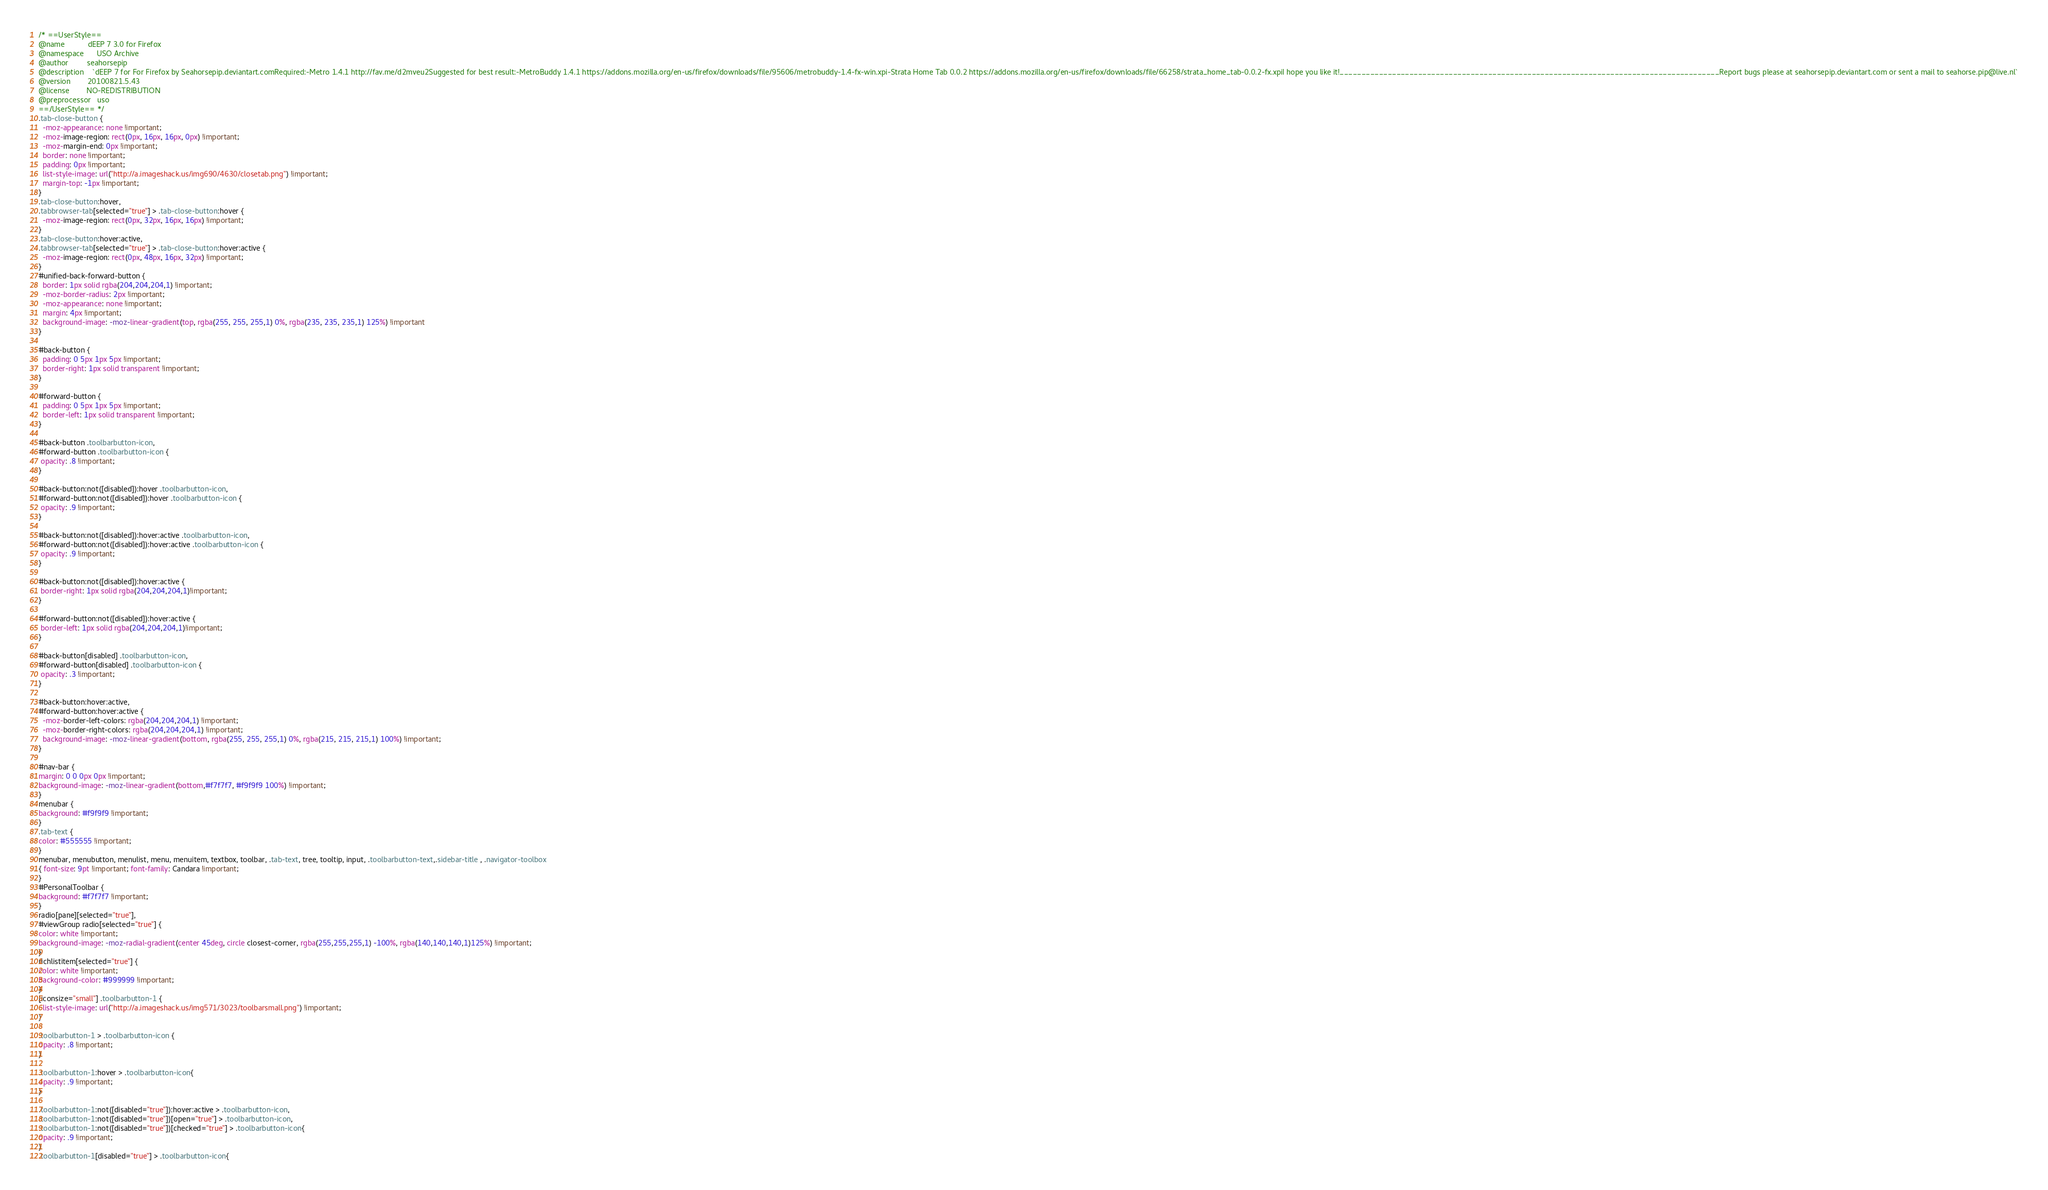<code> <loc_0><loc_0><loc_500><loc_500><_CSS_>/* ==UserStyle==
@name           dEEP 7 3.0 for Firefox
@namespace      USO Archive
@author         seahorsepip
@description    `dEEP 7 for For Firefox by Seahorsepip.deviantart.comRequired:-Metro 1.4.1 http://fav.me/d2mveu2Suggested for best result:-MetroBuddy 1.4.1 https://addons.mozilla.org/en-us/firefox/downloads/file/95606/metrobuddy-1.4-fx-win.xpi-Strata Home Tab 0.0.2 https://addons.mozilla.org/en-us/firefox/downloads/file/66258/strata_home_tab-0.0.2-fx.xpiI hope you like it!_______________________________________________________________________________________Report bugs please at seahorsepip.deviantart.com or sent a mail to seahorse.pip@live.nl`
@version        20100821.5.43
@license        NO-REDISTRIBUTION
@preprocessor   uso
==/UserStyle== */
.tab-close-button {
  -moz-appearance: none !important;
  -moz-image-region: rect(0px, 16px, 16px, 0px) !important;
  -moz-margin-end: 0px !important;
  border: none !important;
  padding: 0px !important;
  list-style-image: url("http://a.imageshack.us/img690/4630/closetab.png") !important;
  margin-top: -1px !important;
}
.tab-close-button:hover,
.tabbrowser-tab[selected="true"] > .tab-close-button:hover {
  -moz-image-region: rect(0px, 32px, 16px, 16px) !important;
}
.tab-close-button:hover:active,
.tabbrowser-tab[selected="true"] > .tab-close-button:hover:active {
  -moz-image-region: rect(0px, 48px, 16px, 32px) !important;
}
#unified-back-forward-button {
  border: 1px solid rgba(204,204,204,1) !important;
  -moz-border-radius: 2px !important;
  -moz-appearance: none !important;
  margin: 4px !important;
  background-image: -moz-linear-gradient(top, rgba(255, 255, 255,1) 0%, rgba(235, 235, 235,1) 125%) !important
}

#back-button {
  padding: 0 5px 1px 5px !important;
  border-right: 1px solid transparent !important;
}

#forward-button {
  padding: 0 5px 1px 5px !important;
  border-left: 1px solid transparent !important;
}

#back-button .toolbarbutton-icon,
#forward-button .toolbarbutton-icon {
 opacity: .8 !important;
}

#back-button:not([disabled]):hover .toolbarbutton-icon,
#forward-button:not([disabled]):hover .toolbarbutton-icon {
 opacity: .9 !important;
}

#back-button:not([disabled]):hover:active .toolbarbutton-icon,
#forward-button:not([disabled]):hover:active .toolbarbutton-icon {
 opacity: .9 !important;
}

#back-button:not([disabled]):hover:active {
 border-right: 1px solid rgba(204,204,204,1)!important;
}

#forward-button:not([disabled]):hover:active {
 border-left: 1px solid rgba(204,204,204,1)!important;
}

#back-button[disabled] .toolbarbutton-icon,
#forward-button[disabled] .toolbarbutton-icon {
 opacity: .3 !important;
}

#back-button:hover:active,
#forward-button:hover:active {
  -moz-border-left-colors: rgba(204,204,204,1) !important;
  -moz-border-right-colors: rgba(204,204,204,1) !important;
  background-image: -moz-linear-gradient(bottom, rgba(255, 255, 255,1) 0%, rgba(215, 215, 215,1) 100%) !important;
}

#nav-bar {
margin: 0 0 0px 0px !important;
background-image: -moz-linear-gradient(bottom,#f7f7f7, #f9f9f9 100%) !important;
}
menubar {
background: #f9f9f9 !important;
}
.tab-text {
color: #555555 !important;
}
menubar, menubutton, menulist, menu, menuitem, textbox, toolbar, .tab-text, tree, tooltip, input, .toolbarbutton-text,.sidebar-title , .navigator-toolbox
{ font-size: 9pt !important; font-family: Candara !important;
}
#PersonalToolbar {
background: #f7f7f7 !important;
}
radio[pane][selected="true"],
#viewGroup radio[selected="true"] {
color: white !important;
background-image: -moz-radial-gradient(center 45deg, circle closest-corner, rgba(255,255,255,1) -100%, rgba(140,140,140,1)125%) !important;
}
richlistitem[selected="true"] {
color: white !important;
background-color: #999999 !important;
}
[iconsize="small"] .toolbarbutton-1 {
  list-style-image: url("http://a.imageshack.us/img571/3023/toolbarsmall.png") !important;
}

.toolbarbutton-1 > .toolbarbutton-icon {
opacity: .8 !important;
}

.toolbarbutton-1:hover > .toolbarbutton-icon{
opacity: .9 !important;
}

.toolbarbutton-1:not([disabled="true"]):hover:active > .toolbarbutton-icon,
.toolbarbutton-1:not([disabled="true"])[open="true"] > .toolbarbutton-icon,
.toolbarbutton-1:not([disabled="true"])[checked="true"] > .toolbarbutton-icon{
opacity: .9 !important;
}
.toolbarbutton-1[disabled="true"] > .toolbarbutton-icon{</code> 